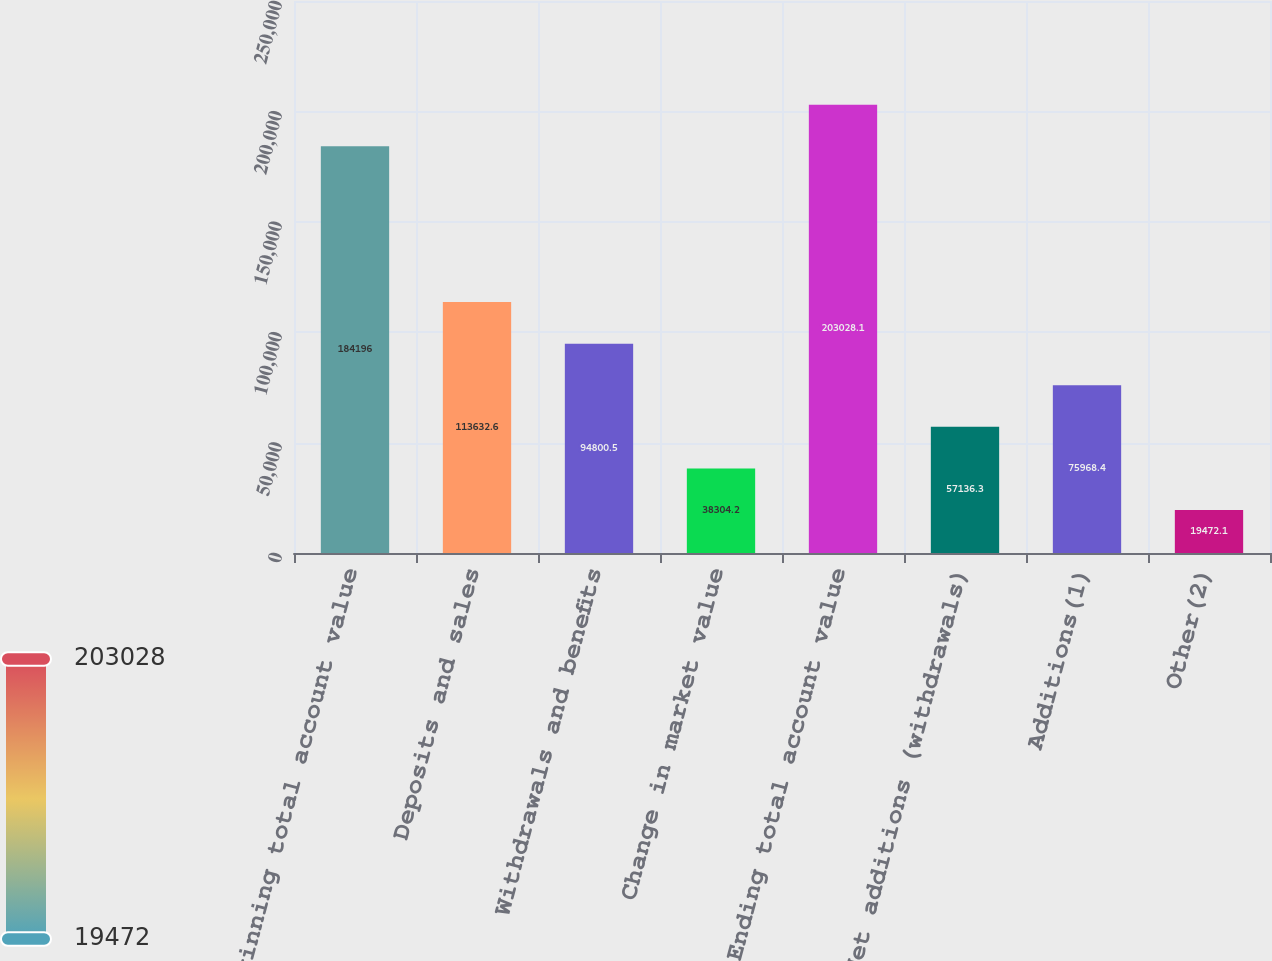<chart> <loc_0><loc_0><loc_500><loc_500><bar_chart><fcel>Beginning total account value<fcel>Deposits and sales<fcel>Withdrawals and benefits<fcel>Change in market value<fcel>Ending total account value<fcel>Net additions (withdrawals)<fcel>Additions(1)<fcel>Other(2)<nl><fcel>184196<fcel>113633<fcel>94800.5<fcel>38304.2<fcel>203028<fcel>57136.3<fcel>75968.4<fcel>19472.1<nl></chart> 